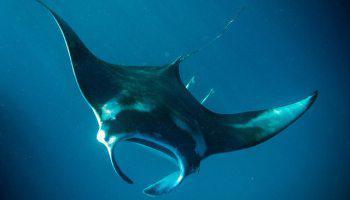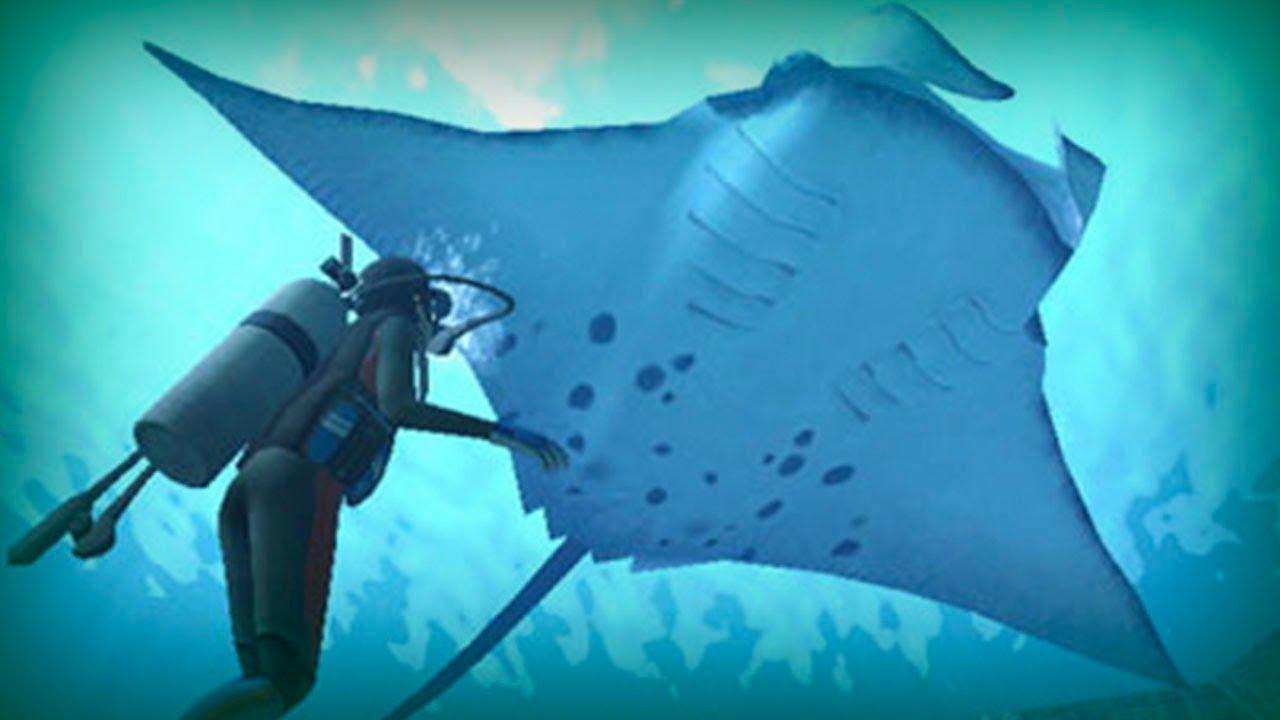The first image is the image on the left, the second image is the image on the right. Examine the images to the left and right. Is the description "There is a scuba diver on one of the images." accurate? Answer yes or no. Yes. 